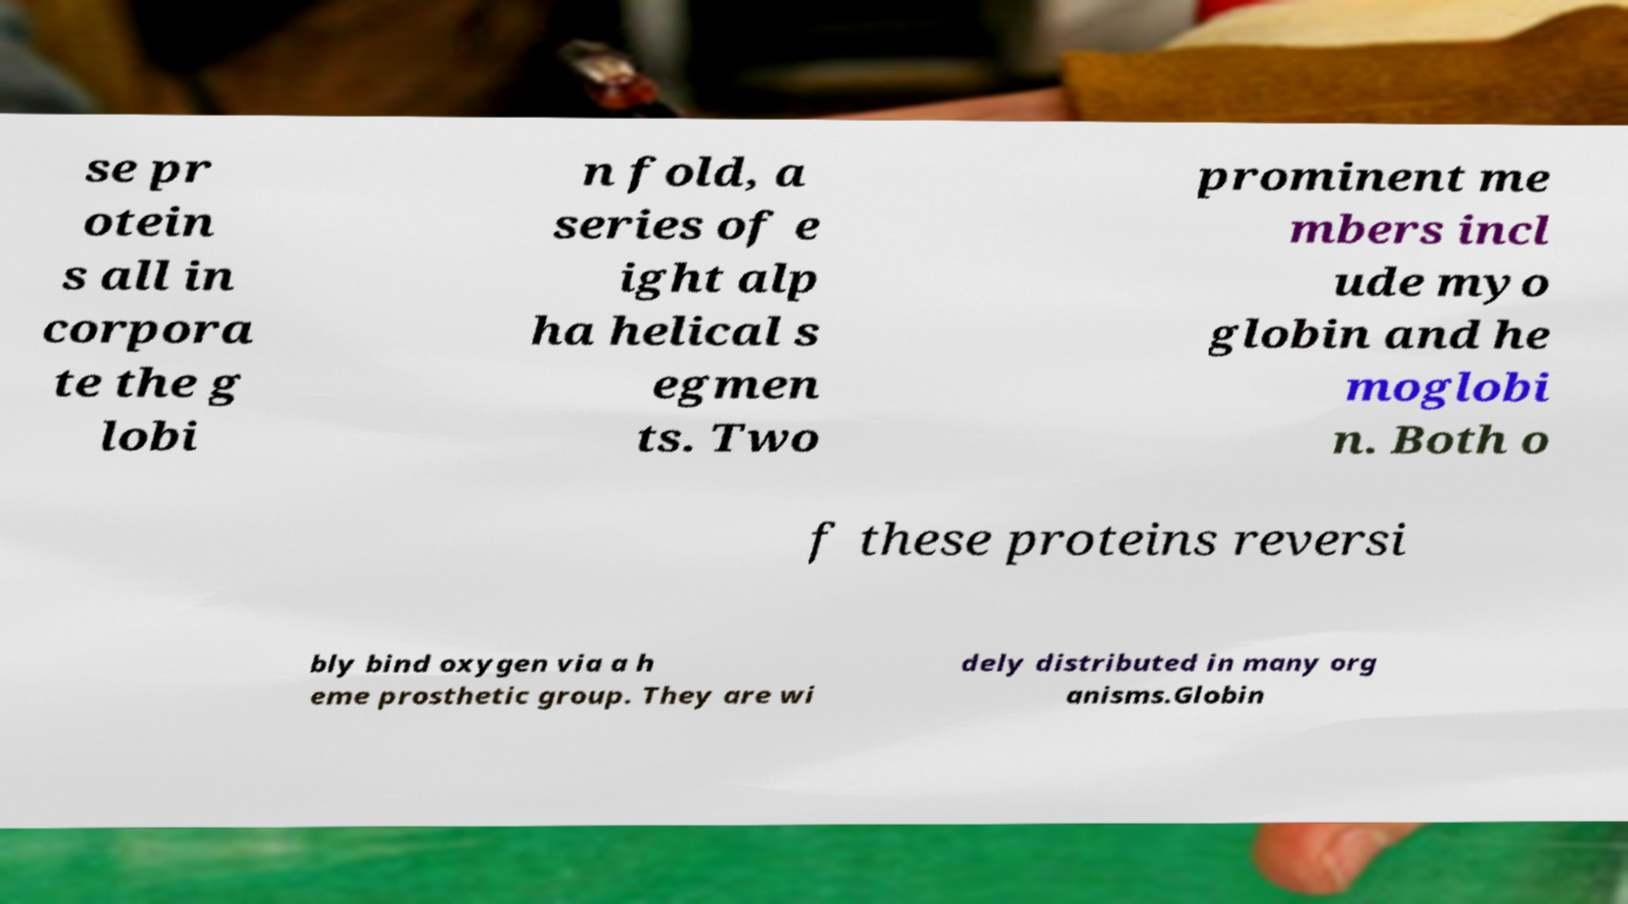Could you extract and type out the text from this image? se pr otein s all in corpora te the g lobi n fold, a series of e ight alp ha helical s egmen ts. Two prominent me mbers incl ude myo globin and he moglobi n. Both o f these proteins reversi bly bind oxygen via a h eme prosthetic group. They are wi dely distributed in many org anisms.Globin 